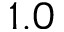Convert formula to latex. <formula><loc_0><loc_0><loc_500><loc_500>1 . 0</formula> 